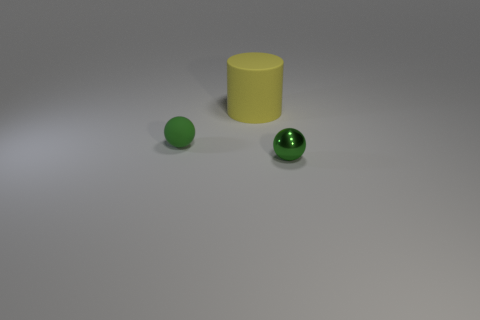What material is the other sphere that is the same color as the rubber ball?
Offer a very short reply. Metal. There is a thing that is behind the small sphere that is on the left side of the yellow matte object; what is its size?
Offer a terse response. Large. Is the color of the small metallic thing the same as the rubber object behind the green rubber ball?
Keep it short and to the point. No. Is there a rubber object of the same size as the green metal ball?
Your answer should be very brief. Yes. How big is the green sphere to the left of the small green shiny object?
Keep it short and to the point. Small. Are there any yellow rubber cylinders that are on the right side of the tiny green matte object behind the tiny metallic object?
Your answer should be compact. Yes. What number of other objects are the same shape as the large yellow rubber object?
Offer a terse response. 0. Do the small shiny object and the big thing have the same shape?
Offer a very short reply. No. The object that is right of the green rubber ball and to the left of the tiny metallic ball is what color?
Your answer should be very brief. Yellow. There is another thing that is the same color as the small metal thing; what size is it?
Provide a short and direct response. Small. 